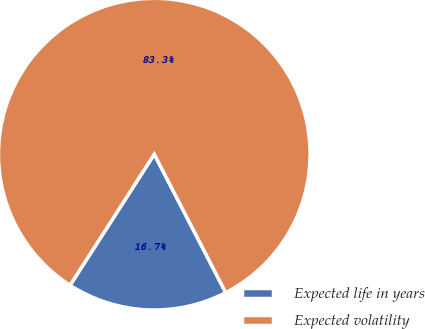Convert chart. <chart><loc_0><loc_0><loc_500><loc_500><pie_chart><fcel>Expected life in years<fcel>Expected volatility<nl><fcel>16.67%<fcel>83.33%<nl></chart> 